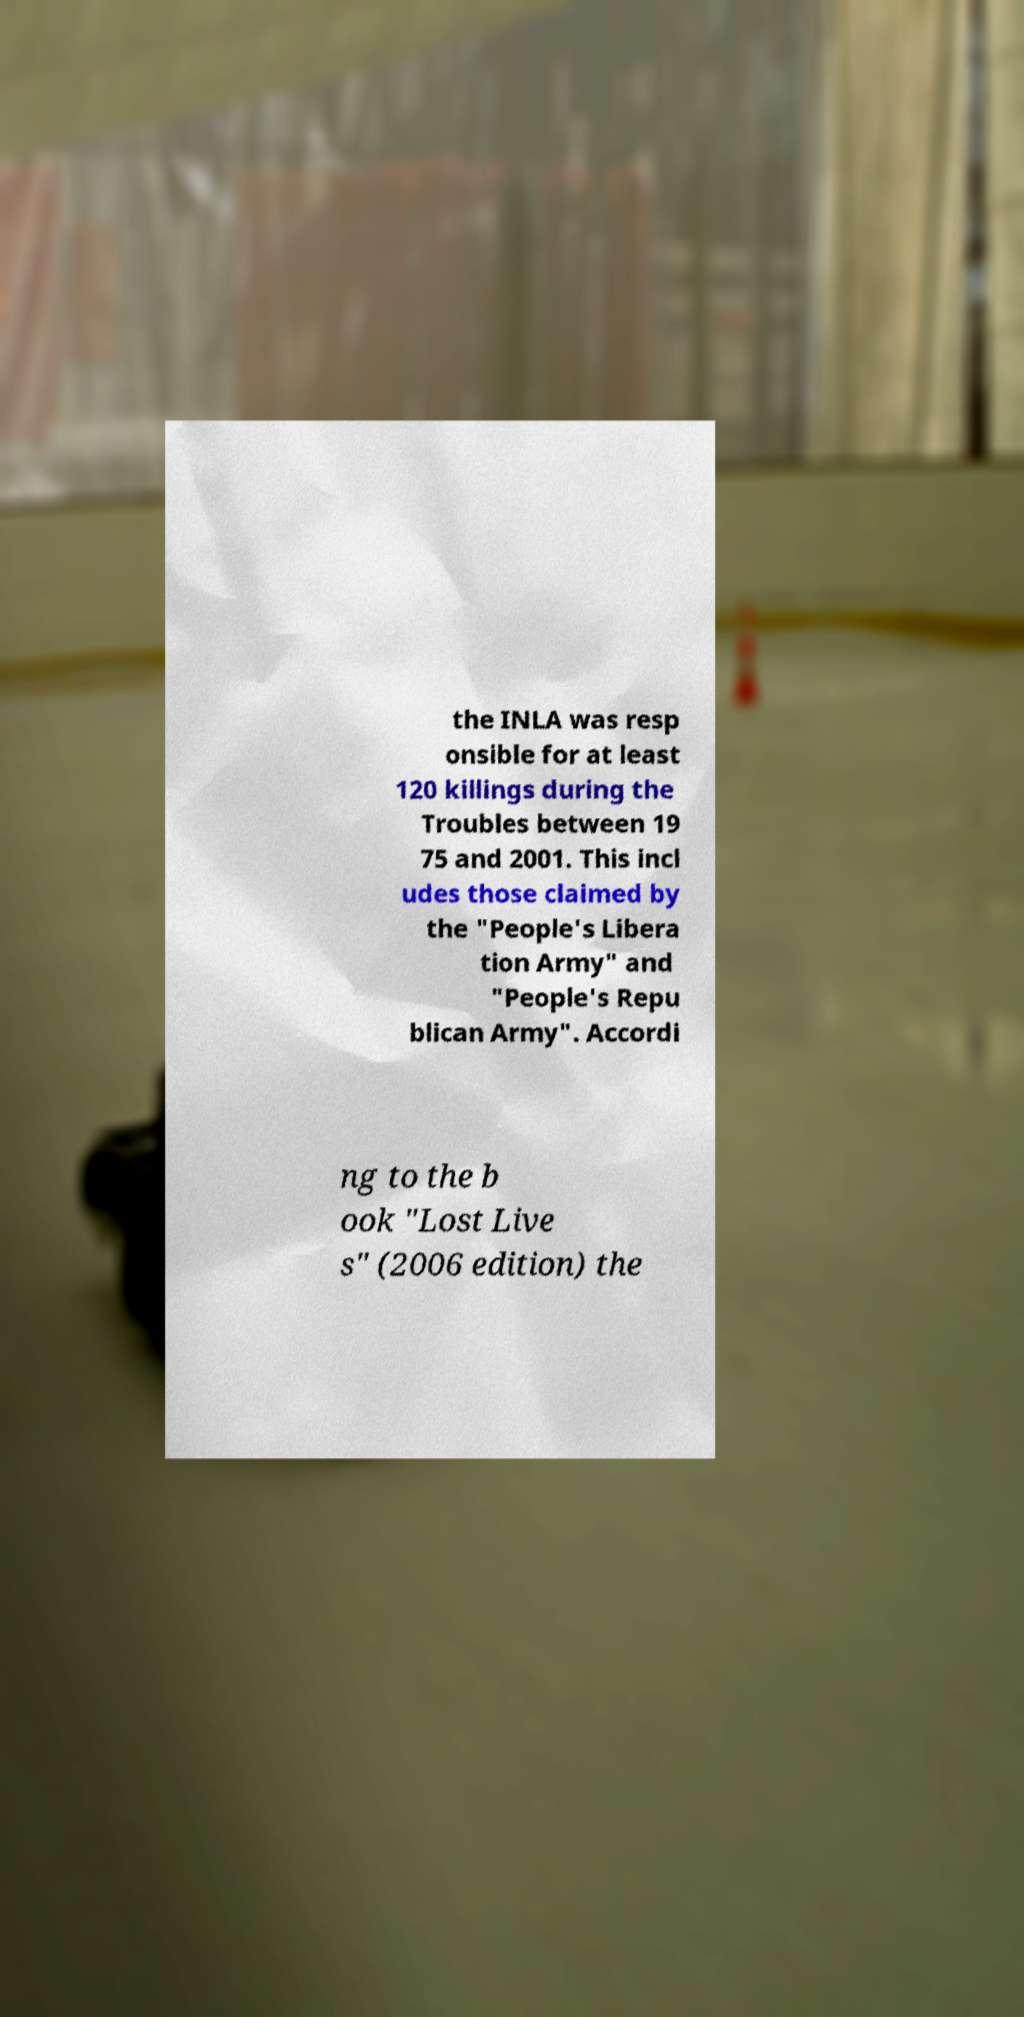Please read and relay the text visible in this image. What does it say? the INLA was resp onsible for at least 120 killings during the Troubles between 19 75 and 2001. This incl udes those claimed by the "People's Libera tion Army" and "People's Repu blican Army". Accordi ng to the b ook "Lost Live s" (2006 edition) the 